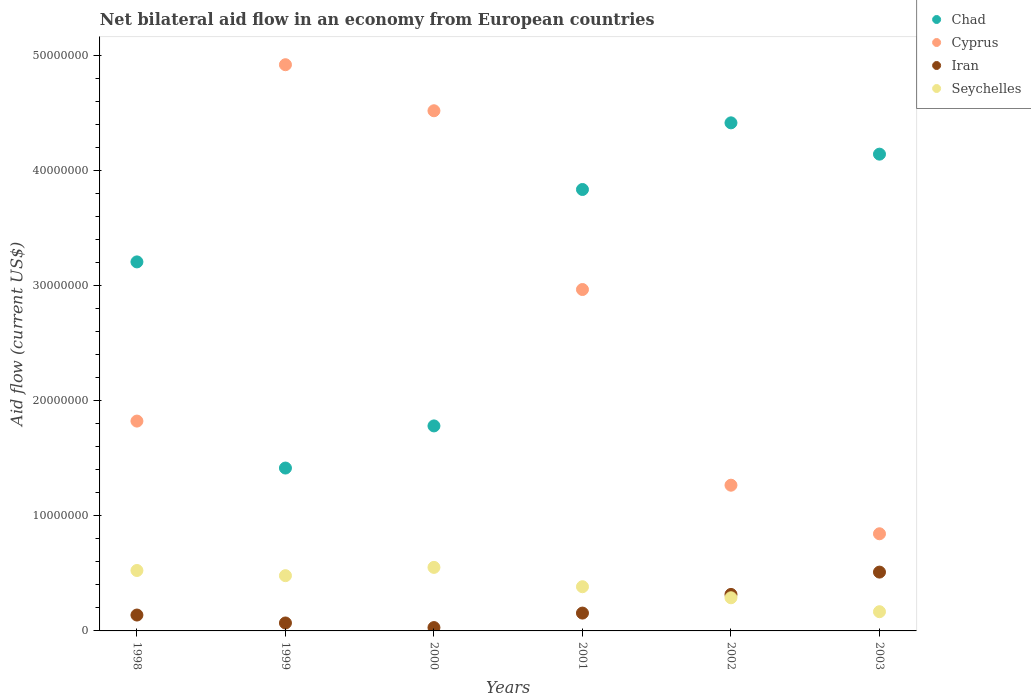What is the net bilateral aid flow in Seychelles in 2000?
Provide a short and direct response. 5.52e+06. Across all years, what is the maximum net bilateral aid flow in Seychelles?
Your answer should be compact. 5.52e+06. Across all years, what is the minimum net bilateral aid flow in Cyprus?
Offer a very short reply. 8.44e+06. In which year was the net bilateral aid flow in Iran maximum?
Your answer should be compact. 2003. What is the total net bilateral aid flow in Iran in the graph?
Ensure brevity in your answer.  1.22e+07. What is the difference between the net bilateral aid flow in Cyprus in 1999 and that in 2000?
Give a very brief answer. 4.00e+06. What is the difference between the net bilateral aid flow in Iran in 2002 and the net bilateral aid flow in Cyprus in 2000?
Offer a very short reply. -4.20e+07. What is the average net bilateral aid flow in Seychelles per year?
Make the answer very short. 3.99e+06. In the year 2003, what is the difference between the net bilateral aid flow in Cyprus and net bilateral aid flow in Seychelles?
Offer a terse response. 6.77e+06. What is the ratio of the net bilateral aid flow in Seychelles in 1998 to that in 2002?
Provide a short and direct response. 1.82. Is the net bilateral aid flow in Chad in 1999 less than that in 2002?
Make the answer very short. Yes. Is the difference between the net bilateral aid flow in Cyprus in 1999 and 2003 greater than the difference between the net bilateral aid flow in Seychelles in 1999 and 2003?
Offer a terse response. Yes. What is the difference between the highest and the second highest net bilateral aid flow in Iran?
Provide a succinct answer. 1.94e+06. What is the difference between the highest and the lowest net bilateral aid flow in Chad?
Provide a short and direct response. 3.00e+07. In how many years, is the net bilateral aid flow in Chad greater than the average net bilateral aid flow in Chad taken over all years?
Keep it short and to the point. 4. Is the sum of the net bilateral aid flow in Seychelles in 1999 and 2001 greater than the maximum net bilateral aid flow in Chad across all years?
Make the answer very short. No. Is it the case that in every year, the sum of the net bilateral aid flow in Chad and net bilateral aid flow in Seychelles  is greater than the net bilateral aid flow in Iran?
Your answer should be compact. Yes. Does the net bilateral aid flow in Seychelles monotonically increase over the years?
Offer a terse response. No. Is the net bilateral aid flow in Seychelles strictly greater than the net bilateral aid flow in Chad over the years?
Provide a short and direct response. No. How many dotlines are there?
Ensure brevity in your answer.  4. Does the graph contain any zero values?
Your response must be concise. No. Does the graph contain grids?
Provide a short and direct response. No. Where does the legend appear in the graph?
Offer a terse response. Top right. What is the title of the graph?
Offer a terse response. Net bilateral aid flow in an economy from European countries. Does "Macao" appear as one of the legend labels in the graph?
Make the answer very short. No. What is the Aid flow (current US$) of Chad in 1998?
Your answer should be compact. 3.21e+07. What is the Aid flow (current US$) in Cyprus in 1998?
Provide a succinct answer. 1.82e+07. What is the Aid flow (current US$) of Iran in 1998?
Ensure brevity in your answer.  1.38e+06. What is the Aid flow (current US$) in Seychelles in 1998?
Keep it short and to the point. 5.25e+06. What is the Aid flow (current US$) of Chad in 1999?
Ensure brevity in your answer.  1.42e+07. What is the Aid flow (current US$) in Cyprus in 1999?
Keep it short and to the point. 4.92e+07. What is the Aid flow (current US$) in Iran in 1999?
Provide a short and direct response. 6.90e+05. What is the Aid flow (current US$) of Seychelles in 1999?
Your answer should be compact. 4.80e+06. What is the Aid flow (current US$) of Chad in 2000?
Keep it short and to the point. 1.78e+07. What is the Aid flow (current US$) in Cyprus in 2000?
Your response must be concise. 4.52e+07. What is the Aid flow (current US$) in Iran in 2000?
Ensure brevity in your answer.  2.90e+05. What is the Aid flow (current US$) in Seychelles in 2000?
Provide a short and direct response. 5.52e+06. What is the Aid flow (current US$) of Chad in 2001?
Give a very brief answer. 3.84e+07. What is the Aid flow (current US$) of Cyprus in 2001?
Provide a succinct answer. 2.97e+07. What is the Aid flow (current US$) in Iran in 2001?
Your answer should be very brief. 1.55e+06. What is the Aid flow (current US$) of Seychelles in 2001?
Keep it short and to the point. 3.84e+06. What is the Aid flow (current US$) of Chad in 2002?
Offer a very short reply. 4.41e+07. What is the Aid flow (current US$) of Cyprus in 2002?
Provide a succinct answer. 1.27e+07. What is the Aid flow (current US$) of Iran in 2002?
Your answer should be very brief. 3.17e+06. What is the Aid flow (current US$) in Seychelles in 2002?
Offer a very short reply. 2.88e+06. What is the Aid flow (current US$) in Chad in 2003?
Provide a succinct answer. 4.14e+07. What is the Aid flow (current US$) of Cyprus in 2003?
Your answer should be compact. 8.44e+06. What is the Aid flow (current US$) of Iran in 2003?
Your answer should be compact. 5.11e+06. What is the Aid flow (current US$) of Seychelles in 2003?
Give a very brief answer. 1.67e+06. Across all years, what is the maximum Aid flow (current US$) in Chad?
Keep it short and to the point. 4.41e+07. Across all years, what is the maximum Aid flow (current US$) in Cyprus?
Your answer should be compact. 4.92e+07. Across all years, what is the maximum Aid flow (current US$) in Iran?
Make the answer very short. 5.11e+06. Across all years, what is the maximum Aid flow (current US$) in Seychelles?
Your response must be concise. 5.52e+06. Across all years, what is the minimum Aid flow (current US$) in Chad?
Ensure brevity in your answer.  1.42e+07. Across all years, what is the minimum Aid flow (current US$) of Cyprus?
Make the answer very short. 8.44e+06. Across all years, what is the minimum Aid flow (current US$) in Seychelles?
Your response must be concise. 1.67e+06. What is the total Aid flow (current US$) of Chad in the graph?
Provide a short and direct response. 1.88e+08. What is the total Aid flow (current US$) of Cyprus in the graph?
Provide a succinct answer. 1.63e+08. What is the total Aid flow (current US$) in Iran in the graph?
Offer a terse response. 1.22e+07. What is the total Aid flow (current US$) in Seychelles in the graph?
Your answer should be compact. 2.40e+07. What is the difference between the Aid flow (current US$) in Chad in 1998 and that in 1999?
Give a very brief answer. 1.79e+07. What is the difference between the Aid flow (current US$) of Cyprus in 1998 and that in 1999?
Offer a very short reply. -3.10e+07. What is the difference between the Aid flow (current US$) in Iran in 1998 and that in 1999?
Make the answer very short. 6.90e+05. What is the difference between the Aid flow (current US$) in Seychelles in 1998 and that in 1999?
Offer a terse response. 4.50e+05. What is the difference between the Aid flow (current US$) in Chad in 1998 and that in 2000?
Give a very brief answer. 1.42e+07. What is the difference between the Aid flow (current US$) in Cyprus in 1998 and that in 2000?
Make the answer very short. -2.70e+07. What is the difference between the Aid flow (current US$) of Iran in 1998 and that in 2000?
Offer a terse response. 1.09e+06. What is the difference between the Aid flow (current US$) in Chad in 1998 and that in 2001?
Keep it short and to the point. -6.29e+06. What is the difference between the Aid flow (current US$) in Cyprus in 1998 and that in 2001?
Give a very brief answer. -1.14e+07. What is the difference between the Aid flow (current US$) in Iran in 1998 and that in 2001?
Keep it short and to the point. -1.70e+05. What is the difference between the Aid flow (current US$) in Seychelles in 1998 and that in 2001?
Offer a terse response. 1.41e+06. What is the difference between the Aid flow (current US$) of Chad in 1998 and that in 2002?
Your answer should be very brief. -1.21e+07. What is the difference between the Aid flow (current US$) in Cyprus in 1998 and that in 2002?
Give a very brief answer. 5.57e+06. What is the difference between the Aid flow (current US$) of Iran in 1998 and that in 2002?
Provide a succinct answer. -1.79e+06. What is the difference between the Aid flow (current US$) of Seychelles in 1998 and that in 2002?
Keep it short and to the point. 2.37e+06. What is the difference between the Aid flow (current US$) in Chad in 1998 and that in 2003?
Offer a very short reply. -9.36e+06. What is the difference between the Aid flow (current US$) of Cyprus in 1998 and that in 2003?
Your response must be concise. 9.79e+06. What is the difference between the Aid flow (current US$) of Iran in 1998 and that in 2003?
Your answer should be compact. -3.73e+06. What is the difference between the Aid flow (current US$) in Seychelles in 1998 and that in 2003?
Provide a succinct answer. 3.58e+06. What is the difference between the Aid flow (current US$) in Chad in 1999 and that in 2000?
Your response must be concise. -3.66e+06. What is the difference between the Aid flow (current US$) of Cyprus in 1999 and that in 2000?
Provide a succinct answer. 4.00e+06. What is the difference between the Aid flow (current US$) in Iran in 1999 and that in 2000?
Provide a short and direct response. 4.00e+05. What is the difference between the Aid flow (current US$) in Seychelles in 1999 and that in 2000?
Give a very brief answer. -7.20e+05. What is the difference between the Aid flow (current US$) in Chad in 1999 and that in 2001?
Keep it short and to the point. -2.42e+07. What is the difference between the Aid flow (current US$) in Cyprus in 1999 and that in 2001?
Your answer should be compact. 1.95e+07. What is the difference between the Aid flow (current US$) of Iran in 1999 and that in 2001?
Your answer should be very brief. -8.60e+05. What is the difference between the Aid flow (current US$) in Seychelles in 1999 and that in 2001?
Provide a succinct answer. 9.60e+05. What is the difference between the Aid flow (current US$) in Chad in 1999 and that in 2002?
Give a very brief answer. -3.00e+07. What is the difference between the Aid flow (current US$) of Cyprus in 1999 and that in 2002?
Your response must be concise. 3.65e+07. What is the difference between the Aid flow (current US$) of Iran in 1999 and that in 2002?
Your answer should be very brief. -2.48e+06. What is the difference between the Aid flow (current US$) of Seychelles in 1999 and that in 2002?
Make the answer very short. 1.92e+06. What is the difference between the Aid flow (current US$) in Chad in 1999 and that in 2003?
Give a very brief answer. -2.73e+07. What is the difference between the Aid flow (current US$) in Cyprus in 1999 and that in 2003?
Offer a very short reply. 4.08e+07. What is the difference between the Aid flow (current US$) of Iran in 1999 and that in 2003?
Make the answer very short. -4.42e+06. What is the difference between the Aid flow (current US$) in Seychelles in 1999 and that in 2003?
Make the answer very short. 3.13e+06. What is the difference between the Aid flow (current US$) of Chad in 2000 and that in 2001?
Give a very brief answer. -2.05e+07. What is the difference between the Aid flow (current US$) in Cyprus in 2000 and that in 2001?
Keep it short and to the point. 1.55e+07. What is the difference between the Aid flow (current US$) of Iran in 2000 and that in 2001?
Offer a very short reply. -1.26e+06. What is the difference between the Aid flow (current US$) of Seychelles in 2000 and that in 2001?
Make the answer very short. 1.68e+06. What is the difference between the Aid flow (current US$) in Chad in 2000 and that in 2002?
Keep it short and to the point. -2.63e+07. What is the difference between the Aid flow (current US$) of Cyprus in 2000 and that in 2002?
Offer a terse response. 3.25e+07. What is the difference between the Aid flow (current US$) of Iran in 2000 and that in 2002?
Your answer should be compact. -2.88e+06. What is the difference between the Aid flow (current US$) of Seychelles in 2000 and that in 2002?
Your answer should be very brief. 2.64e+06. What is the difference between the Aid flow (current US$) of Chad in 2000 and that in 2003?
Offer a very short reply. -2.36e+07. What is the difference between the Aid flow (current US$) of Cyprus in 2000 and that in 2003?
Your answer should be very brief. 3.68e+07. What is the difference between the Aid flow (current US$) in Iran in 2000 and that in 2003?
Make the answer very short. -4.82e+06. What is the difference between the Aid flow (current US$) in Seychelles in 2000 and that in 2003?
Provide a short and direct response. 3.85e+06. What is the difference between the Aid flow (current US$) in Chad in 2001 and that in 2002?
Your response must be concise. -5.79e+06. What is the difference between the Aid flow (current US$) of Cyprus in 2001 and that in 2002?
Give a very brief answer. 1.70e+07. What is the difference between the Aid flow (current US$) of Iran in 2001 and that in 2002?
Your answer should be compact. -1.62e+06. What is the difference between the Aid flow (current US$) of Seychelles in 2001 and that in 2002?
Ensure brevity in your answer.  9.60e+05. What is the difference between the Aid flow (current US$) of Chad in 2001 and that in 2003?
Keep it short and to the point. -3.07e+06. What is the difference between the Aid flow (current US$) of Cyprus in 2001 and that in 2003?
Provide a short and direct response. 2.12e+07. What is the difference between the Aid flow (current US$) in Iran in 2001 and that in 2003?
Provide a short and direct response. -3.56e+06. What is the difference between the Aid flow (current US$) of Seychelles in 2001 and that in 2003?
Your answer should be compact. 2.17e+06. What is the difference between the Aid flow (current US$) of Chad in 2002 and that in 2003?
Make the answer very short. 2.72e+06. What is the difference between the Aid flow (current US$) of Cyprus in 2002 and that in 2003?
Keep it short and to the point. 4.22e+06. What is the difference between the Aid flow (current US$) in Iran in 2002 and that in 2003?
Provide a short and direct response. -1.94e+06. What is the difference between the Aid flow (current US$) in Seychelles in 2002 and that in 2003?
Your answer should be compact. 1.21e+06. What is the difference between the Aid flow (current US$) of Chad in 1998 and the Aid flow (current US$) of Cyprus in 1999?
Make the answer very short. -1.71e+07. What is the difference between the Aid flow (current US$) in Chad in 1998 and the Aid flow (current US$) in Iran in 1999?
Offer a terse response. 3.14e+07. What is the difference between the Aid flow (current US$) of Chad in 1998 and the Aid flow (current US$) of Seychelles in 1999?
Your answer should be very brief. 2.73e+07. What is the difference between the Aid flow (current US$) in Cyprus in 1998 and the Aid flow (current US$) in Iran in 1999?
Make the answer very short. 1.75e+07. What is the difference between the Aid flow (current US$) in Cyprus in 1998 and the Aid flow (current US$) in Seychelles in 1999?
Give a very brief answer. 1.34e+07. What is the difference between the Aid flow (current US$) in Iran in 1998 and the Aid flow (current US$) in Seychelles in 1999?
Your response must be concise. -3.42e+06. What is the difference between the Aid flow (current US$) of Chad in 1998 and the Aid flow (current US$) of Cyprus in 2000?
Provide a short and direct response. -1.31e+07. What is the difference between the Aid flow (current US$) in Chad in 1998 and the Aid flow (current US$) in Iran in 2000?
Your answer should be very brief. 3.18e+07. What is the difference between the Aid flow (current US$) in Chad in 1998 and the Aid flow (current US$) in Seychelles in 2000?
Your answer should be compact. 2.65e+07. What is the difference between the Aid flow (current US$) of Cyprus in 1998 and the Aid flow (current US$) of Iran in 2000?
Your response must be concise. 1.79e+07. What is the difference between the Aid flow (current US$) in Cyprus in 1998 and the Aid flow (current US$) in Seychelles in 2000?
Keep it short and to the point. 1.27e+07. What is the difference between the Aid flow (current US$) of Iran in 1998 and the Aid flow (current US$) of Seychelles in 2000?
Offer a terse response. -4.14e+06. What is the difference between the Aid flow (current US$) of Chad in 1998 and the Aid flow (current US$) of Cyprus in 2001?
Give a very brief answer. 2.40e+06. What is the difference between the Aid flow (current US$) of Chad in 1998 and the Aid flow (current US$) of Iran in 2001?
Keep it short and to the point. 3.05e+07. What is the difference between the Aid flow (current US$) in Chad in 1998 and the Aid flow (current US$) in Seychelles in 2001?
Give a very brief answer. 2.82e+07. What is the difference between the Aid flow (current US$) of Cyprus in 1998 and the Aid flow (current US$) of Iran in 2001?
Give a very brief answer. 1.67e+07. What is the difference between the Aid flow (current US$) of Cyprus in 1998 and the Aid flow (current US$) of Seychelles in 2001?
Make the answer very short. 1.44e+07. What is the difference between the Aid flow (current US$) in Iran in 1998 and the Aid flow (current US$) in Seychelles in 2001?
Give a very brief answer. -2.46e+06. What is the difference between the Aid flow (current US$) of Chad in 1998 and the Aid flow (current US$) of Cyprus in 2002?
Offer a very short reply. 1.94e+07. What is the difference between the Aid flow (current US$) in Chad in 1998 and the Aid flow (current US$) in Iran in 2002?
Keep it short and to the point. 2.89e+07. What is the difference between the Aid flow (current US$) in Chad in 1998 and the Aid flow (current US$) in Seychelles in 2002?
Your answer should be very brief. 2.92e+07. What is the difference between the Aid flow (current US$) of Cyprus in 1998 and the Aid flow (current US$) of Iran in 2002?
Make the answer very short. 1.51e+07. What is the difference between the Aid flow (current US$) in Cyprus in 1998 and the Aid flow (current US$) in Seychelles in 2002?
Offer a terse response. 1.54e+07. What is the difference between the Aid flow (current US$) in Iran in 1998 and the Aid flow (current US$) in Seychelles in 2002?
Your answer should be compact. -1.50e+06. What is the difference between the Aid flow (current US$) in Chad in 1998 and the Aid flow (current US$) in Cyprus in 2003?
Your answer should be very brief. 2.36e+07. What is the difference between the Aid flow (current US$) of Chad in 1998 and the Aid flow (current US$) of Iran in 2003?
Provide a short and direct response. 2.70e+07. What is the difference between the Aid flow (current US$) of Chad in 1998 and the Aid flow (current US$) of Seychelles in 2003?
Make the answer very short. 3.04e+07. What is the difference between the Aid flow (current US$) in Cyprus in 1998 and the Aid flow (current US$) in Iran in 2003?
Offer a terse response. 1.31e+07. What is the difference between the Aid flow (current US$) in Cyprus in 1998 and the Aid flow (current US$) in Seychelles in 2003?
Provide a succinct answer. 1.66e+07. What is the difference between the Aid flow (current US$) of Chad in 1999 and the Aid flow (current US$) of Cyprus in 2000?
Offer a very short reply. -3.10e+07. What is the difference between the Aid flow (current US$) of Chad in 1999 and the Aid flow (current US$) of Iran in 2000?
Provide a short and direct response. 1.39e+07. What is the difference between the Aid flow (current US$) of Chad in 1999 and the Aid flow (current US$) of Seychelles in 2000?
Give a very brief answer. 8.63e+06. What is the difference between the Aid flow (current US$) of Cyprus in 1999 and the Aid flow (current US$) of Iran in 2000?
Your answer should be compact. 4.89e+07. What is the difference between the Aid flow (current US$) in Cyprus in 1999 and the Aid flow (current US$) in Seychelles in 2000?
Your response must be concise. 4.37e+07. What is the difference between the Aid flow (current US$) of Iran in 1999 and the Aid flow (current US$) of Seychelles in 2000?
Ensure brevity in your answer.  -4.83e+06. What is the difference between the Aid flow (current US$) of Chad in 1999 and the Aid flow (current US$) of Cyprus in 2001?
Provide a succinct answer. -1.55e+07. What is the difference between the Aid flow (current US$) of Chad in 1999 and the Aid flow (current US$) of Iran in 2001?
Ensure brevity in your answer.  1.26e+07. What is the difference between the Aid flow (current US$) of Chad in 1999 and the Aid flow (current US$) of Seychelles in 2001?
Ensure brevity in your answer.  1.03e+07. What is the difference between the Aid flow (current US$) in Cyprus in 1999 and the Aid flow (current US$) in Iran in 2001?
Your answer should be compact. 4.76e+07. What is the difference between the Aid flow (current US$) of Cyprus in 1999 and the Aid flow (current US$) of Seychelles in 2001?
Give a very brief answer. 4.54e+07. What is the difference between the Aid flow (current US$) in Iran in 1999 and the Aid flow (current US$) in Seychelles in 2001?
Make the answer very short. -3.15e+06. What is the difference between the Aid flow (current US$) in Chad in 1999 and the Aid flow (current US$) in Cyprus in 2002?
Provide a succinct answer. 1.49e+06. What is the difference between the Aid flow (current US$) of Chad in 1999 and the Aid flow (current US$) of Iran in 2002?
Offer a very short reply. 1.10e+07. What is the difference between the Aid flow (current US$) of Chad in 1999 and the Aid flow (current US$) of Seychelles in 2002?
Provide a succinct answer. 1.13e+07. What is the difference between the Aid flow (current US$) in Cyprus in 1999 and the Aid flow (current US$) in Iran in 2002?
Provide a short and direct response. 4.60e+07. What is the difference between the Aid flow (current US$) in Cyprus in 1999 and the Aid flow (current US$) in Seychelles in 2002?
Offer a terse response. 4.63e+07. What is the difference between the Aid flow (current US$) in Iran in 1999 and the Aid flow (current US$) in Seychelles in 2002?
Provide a succinct answer. -2.19e+06. What is the difference between the Aid flow (current US$) in Chad in 1999 and the Aid flow (current US$) in Cyprus in 2003?
Your answer should be very brief. 5.71e+06. What is the difference between the Aid flow (current US$) in Chad in 1999 and the Aid flow (current US$) in Iran in 2003?
Offer a terse response. 9.04e+06. What is the difference between the Aid flow (current US$) in Chad in 1999 and the Aid flow (current US$) in Seychelles in 2003?
Ensure brevity in your answer.  1.25e+07. What is the difference between the Aid flow (current US$) in Cyprus in 1999 and the Aid flow (current US$) in Iran in 2003?
Ensure brevity in your answer.  4.41e+07. What is the difference between the Aid flow (current US$) of Cyprus in 1999 and the Aid flow (current US$) of Seychelles in 2003?
Make the answer very short. 4.75e+07. What is the difference between the Aid flow (current US$) in Iran in 1999 and the Aid flow (current US$) in Seychelles in 2003?
Provide a short and direct response. -9.80e+05. What is the difference between the Aid flow (current US$) in Chad in 2000 and the Aid flow (current US$) in Cyprus in 2001?
Your answer should be compact. -1.18e+07. What is the difference between the Aid flow (current US$) in Chad in 2000 and the Aid flow (current US$) in Iran in 2001?
Your answer should be very brief. 1.63e+07. What is the difference between the Aid flow (current US$) in Chad in 2000 and the Aid flow (current US$) in Seychelles in 2001?
Provide a succinct answer. 1.40e+07. What is the difference between the Aid flow (current US$) of Cyprus in 2000 and the Aid flow (current US$) of Iran in 2001?
Your answer should be very brief. 4.36e+07. What is the difference between the Aid flow (current US$) of Cyprus in 2000 and the Aid flow (current US$) of Seychelles in 2001?
Your answer should be very brief. 4.14e+07. What is the difference between the Aid flow (current US$) of Iran in 2000 and the Aid flow (current US$) of Seychelles in 2001?
Your answer should be very brief. -3.55e+06. What is the difference between the Aid flow (current US$) of Chad in 2000 and the Aid flow (current US$) of Cyprus in 2002?
Offer a very short reply. 5.15e+06. What is the difference between the Aid flow (current US$) in Chad in 2000 and the Aid flow (current US$) in Iran in 2002?
Ensure brevity in your answer.  1.46e+07. What is the difference between the Aid flow (current US$) in Chad in 2000 and the Aid flow (current US$) in Seychelles in 2002?
Your answer should be compact. 1.49e+07. What is the difference between the Aid flow (current US$) of Cyprus in 2000 and the Aid flow (current US$) of Iran in 2002?
Offer a terse response. 4.20e+07. What is the difference between the Aid flow (current US$) of Cyprus in 2000 and the Aid flow (current US$) of Seychelles in 2002?
Ensure brevity in your answer.  4.23e+07. What is the difference between the Aid flow (current US$) of Iran in 2000 and the Aid flow (current US$) of Seychelles in 2002?
Provide a short and direct response. -2.59e+06. What is the difference between the Aid flow (current US$) in Chad in 2000 and the Aid flow (current US$) in Cyprus in 2003?
Offer a terse response. 9.37e+06. What is the difference between the Aid flow (current US$) in Chad in 2000 and the Aid flow (current US$) in Iran in 2003?
Keep it short and to the point. 1.27e+07. What is the difference between the Aid flow (current US$) of Chad in 2000 and the Aid flow (current US$) of Seychelles in 2003?
Your answer should be compact. 1.61e+07. What is the difference between the Aid flow (current US$) in Cyprus in 2000 and the Aid flow (current US$) in Iran in 2003?
Your response must be concise. 4.01e+07. What is the difference between the Aid flow (current US$) in Cyprus in 2000 and the Aid flow (current US$) in Seychelles in 2003?
Provide a succinct answer. 4.35e+07. What is the difference between the Aid flow (current US$) in Iran in 2000 and the Aid flow (current US$) in Seychelles in 2003?
Provide a succinct answer. -1.38e+06. What is the difference between the Aid flow (current US$) in Chad in 2001 and the Aid flow (current US$) in Cyprus in 2002?
Keep it short and to the point. 2.57e+07. What is the difference between the Aid flow (current US$) of Chad in 2001 and the Aid flow (current US$) of Iran in 2002?
Your answer should be compact. 3.52e+07. What is the difference between the Aid flow (current US$) of Chad in 2001 and the Aid flow (current US$) of Seychelles in 2002?
Ensure brevity in your answer.  3.55e+07. What is the difference between the Aid flow (current US$) of Cyprus in 2001 and the Aid flow (current US$) of Iran in 2002?
Your answer should be very brief. 2.65e+07. What is the difference between the Aid flow (current US$) in Cyprus in 2001 and the Aid flow (current US$) in Seychelles in 2002?
Offer a very short reply. 2.68e+07. What is the difference between the Aid flow (current US$) in Iran in 2001 and the Aid flow (current US$) in Seychelles in 2002?
Ensure brevity in your answer.  -1.33e+06. What is the difference between the Aid flow (current US$) in Chad in 2001 and the Aid flow (current US$) in Cyprus in 2003?
Provide a short and direct response. 2.99e+07. What is the difference between the Aid flow (current US$) in Chad in 2001 and the Aid flow (current US$) in Iran in 2003?
Your response must be concise. 3.32e+07. What is the difference between the Aid flow (current US$) in Chad in 2001 and the Aid flow (current US$) in Seychelles in 2003?
Provide a short and direct response. 3.67e+07. What is the difference between the Aid flow (current US$) in Cyprus in 2001 and the Aid flow (current US$) in Iran in 2003?
Provide a short and direct response. 2.46e+07. What is the difference between the Aid flow (current US$) of Cyprus in 2001 and the Aid flow (current US$) of Seychelles in 2003?
Keep it short and to the point. 2.80e+07. What is the difference between the Aid flow (current US$) in Chad in 2002 and the Aid flow (current US$) in Cyprus in 2003?
Offer a very short reply. 3.57e+07. What is the difference between the Aid flow (current US$) of Chad in 2002 and the Aid flow (current US$) of Iran in 2003?
Your answer should be very brief. 3.90e+07. What is the difference between the Aid flow (current US$) in Chad in 2002 and the Aid flow (current US$) in Seychelles in 2003?
Provide a succinct answer. 4.25e+07. What is the difference between the Aid flow (current US$) of Cyprus in 2002 and the Aid flow (current US$) of Iran in 2003?
Offer a terse response. 7.55e+06. What is the difference between the Aid flow (current US$) in Cyprus in 2002 and the Aid flow (current US$) in Seychelles in 2003?
Keep it short and to the point. 1.10e+07. What is the difference between the Aid flow (current US$) of Iran in 2002 and the Aid flow (current US$) of Seychelles in 2003?
Offer a very short reply. 1.50e+06. What is the average Aid flow (current US$) in Chad per year?
Offer a terse response. 3.13e+07. What is the average Aid flow (current US$) in Cyprus per year?
Provide a succinct answer. 2.72e+07. What is the average Aid flow (current US$) of Iran per year?
Offer a very short reply. 2.03e+06. What is the average Aid flow (current US$) in Seychelles per year?
Your answer should be very brief. 3.99e+06. In the year 1998, what is the difference between the Aid flow (current US$) in Chad and Aid flow (current US$) in Cyprus?
Ensure brevity in your answer.  1.38e+07. In the year 1998, what is the difference between the Aid flow (current US$) in Chad and Aid flow (current US$) in Iran?
Ensure brevity in your answer.  3.07e+07. In the year 1998, what is the difference between the Aid flow (current US$) in Chad and Aid flow (current US$) in Seychelles?
Offer a very short reply. 2.68e+07. In the year 1998, what is the difference between the Aid flow (current US$) in Cyprus and Aid flow (current US$) in Iran?
Your response must be concise. 1.68e+07. In the year 1998, what is the difference between the Aid flow (current US$) in Cyprus and Aid flow (current US$) in Seychelles?
Make the answer very short. 1.30e+07. In the year 1998, what is the difference between the Aid flow (current US$) of Iran and Aid flow (current US$) of Seychelles?
Keep it short and to the point. -3.87e+06. In the year 1999, what is the difference between the Aid flow (current US$) in Chad and Aid flow (current US$) in Cyprus?
Your answer should be compact. -3.50e+07. In the year 1999, what is the difference between the Aid flow (current US$) in Chad and Aid flow (current US$) in Iran?
Your answer should be very brief. 1.35e+07. In the year 1999, what is the difference between the Aid flow (current US$) of Chad and Aid flow (current US$) of Seychelles?
Offer a very short reply. 9.35e+06. In the year 1999, what is the difference between the Aid flow (current US$) of Cyprus and Aid flow (current US$) of Iran?
Give a very brief answer. 4.85e+07. In the year 1999, what is the difference between the Aid flow (current US$) of Cyprus and Aid flow (current US$) of Seychelles?
Your answer should be very brief. 4.44e+07. In the year 1999, what is the difference between the Aid flow (current US$) of Iran and Aid flow (current US$) of Seychelles?
Offer a terse response. -4.11e+06. In the year 2000, what is the difference between the Aid flow (current US$) of Chad and Aid flow (current US$) of Cyprus?
Make the answer very short. -2.74e+07. In the year 2000, what is the difference between the Aid flow (current US$) in Chad and Aid flow (current US$) in Iran?
Offer a terse response. 1.75e+07. In the year 2000, what is the difference between the Aid flow (current US$) in Chad and Aid flow (current US$) in Seychelles?
Keep it short and to the point. 1.23e+07. In the year 2000, what is the difference between the Aid flow (current US$) in Cyprus and Aid flow (current US$) in Iran?
Your response must be concise. 4.49e+07. In the year 2000, what is the difference between the Aid flow (current US$) of Cyprus and Aid flow (current US$) of Seychelles?
Keep it short and to the point. 3.97e+07. In the year 2000, what is the difference between the Aid flow (current US$) of Iran and Aid flow (current US$) of Seychelles?
Your response must be concise. -5.23e+06. In the year 2001, what is the difference between the Aid flow (current US$) of Chad and Aid flow (current US$) of Cyprus?
Your response must be concise. 8.69e+06. In the year 2001, what is the difference between the Aid flow (current US$) in Chad and Aid flow (current US$) in Iran?
Provide a short and direct response. 3.68e+07. In the year 2001, what is the difference between the Aid flow (current US$) of Chad and Aid flow (current US$) of Seychelles?
Provide a succinct answer. 3.45e+07. In the year 2001, what is the difference between the Aid flow (current US$) of Cyprus and Aid flow (current US$) of Iran?
Offer a terse response. 2.81e+07. In the year 2001, what is the difference between the Aid flow (current US$) of Cyprus and Aid flow (current US$) of Seychelles?
Offer a very short reply. 2.58e+07. In the year 2001, what is the difference between the Aid flow (current US$) of Iran and Aid flow (current US$) of Seychelles?
Your answer should be compact. -2.29e+06. In the year 2002, what is the difference between the Aid flow (current US$) in Chad and Aid flow (current US$) in Cyprus?
Give a very brief answer. 3.15e+07. In the year 2002, what is the difference between the Aid flow (current US$) of Chad and Aid flow (current US$) of Iran?
Your response must be concise. 4.10e+07. In the year 2002, what is the difference between the Aid flow (current US$) of Chad and Aid flow (current US$) of Seychelles?
Your response must be concise. 4.13e+07. In the year 2002, what is the difference between the Aid flow (current US$) of Cyprus and Aid flow (current US$) of Iran?
Your response must be concise. 9.49e+06. In the year 2002, what is the difference between the Aid flow (current US$) of Cyprus and Aid flow (current US$) of Seychelles?
Keep it short and to the point. 9.78e+06. In the year 2003, what is the difference between the Aid flow (current US$) in Chad and Aid flow (current US$) in Cyprus?
Provide a short and direct response. 3.30e+07. In the year 2003, what is the difference between the Aid flow (current US$) in Chad and Aid flow (current US$) in Iran?
Provide a short and direct response. 3.63e+07. In the year 2003, what is the difference between the Aid flow (current US$) of Chad and Aid flow (current US$) of Seychelles?
Ensure brevity in your answer.  3.98e+07. In the year 2003, what is the difference between the Aid flow (current US$) in Cyprus and Aid flow (current US$) in Iran?
Your response must be concise. 3.33e+06. In the year 2003, what is the difference between the Aid flow (current US$) in Cyprus and Aid flow (current US$) in Seychelles?
Offer a very short reply. 6.77e+06. In the year 2003, what is the difference between the Aid flow (current US$) in Iran and Aid flow (current US$) in Seychelles?
Keep it short and to the point. 3.44e+06. What is the ratio of the Aid flow (current US$) of Chad in 1998 to that in 1999?
Ensure brevity in your answer.  2.27. What is the ratio of the Aid flow (current US$) of Cyprus in 1998 to that in 1999?
Offer a very short reply. 0.37. What is the ratio of the Aid flow (current US$) in Seychelles in 1998 to that in 1999?
Offer a very short reply. 1.09. What is the ratio of the Aid flow (current US$) in Chad in 1998 to that in 2000?
Keep it short and to the point. 1.8. What is the ratio of the Aid flow (current US$) in Cyprus in 1998 to that in 2000?
Provide a succinct answer. 0.4. What is the ratio of the Aid flow (current US$) in Iran in 1998 to that in 2000?
Your answer should be compact. 4.76. What is the ratio of the Aid flow (current US$) of Seychelles in 1998 to that in 2000?
Offer a terse response. 0.95. What is the ratio of the Aid flow (current US$) in Chad in 1998 to that in 2001?
Provide a short and direct response. 0.84. What is the ratio of the Aid flow (current US$) of Cyprus in 1998 to that in 2001?
Give a very brief answer. 0.61. What is the ratio of the Aid flow (current US$) of Iran in 1998 to that in 2001?
Keep it short and to the point. 0.89. What is the ratio of the Aid flow (current US$) in Seychelles in 1998 to that in 2001?
Provide a short and direct response. 1.37. What is the ratio of the Aid flow (current US$) of Chad in 1998 to that in 2002?
Your response must be concise. 0.73. What is the ratio of the Aid flow (current US$) in Cyprus in 1998 to that in 2002?
Your response must be concise. 1.44. What is the ratio of the Aid flow (current US$) in Iran in 1998 to that in 2002?
Ensure brevity in your answer.  0.44. What is the ratio of the Aid flow (current US$) of Seychelles in 1998 to that in 2002?
Provide a short and direct response. 1.82. What is the ratio of the Aid flow (current US$) in Chad in 1998 to that in 2003?
Provide a succinct answer. 0.77. What is the ratio of the Aid flow (current US$) in Cyprus in 1998 to that in 2003?
Give a very brief answer. 2.16. What is the ratio of the Aid flow (current US$) in Iran in 1998 to that in 2003?
Make the answer very short. 0.27. What is the ratio of the Aid flow (current US$) in Seychelles in 1998 to that in 2003?
Give a very brief answer. 3.14. What is the ratio of the Aid flow (current US$) of Chad in 1999 to that in 2000?
Your response must be concise. 0.79. What is the ratio of the Aid flow (current US$) of Cyprus in 1999 to that in 2000?
Your answer should be compact. 1.09. What is the ratio of the Aid flow (current US$) of Iran in 1999 to that in 2000?
Offer a very short reply. 2.38. What is the ratio of the Aid flow (current US$) of Seychelles in 1999 to that in 2000?
Ensure brevity in your answer.  0.87. What is the ratio of the Aid flow (current US$) of Chad in 1999 to that in 2001?
Give a very brief answer. 0.37. What is the ratio of the Aid flow (current US$) of Cyprus in 1999 to that in 2001?
Your response must be concise. 1.66. What is the ratio of the Aid flow (current US$) of Iran in 1999 to that in 2001?
Offer a very short reply. 0.45. What is the ratio of the Aid flow (current US$) of Chad in 1999 to that in 2002?
Ensure brevity in your answer.  0.32. What is the ratio of the Aid flow (current US$) of Cyprus in 1999 to that in 2002?
Ensure brevity in your answer.  3.89. What is the ratio of the Aid flow (current US$) in Iran in 1999 to that in 2002?
Your answer should be very brief. 0.22. What is the ratio of the Aid flow (current US$) of Chad in 1999 to that in 2003?
Offer a terse response. 0.34. What is the ratio of the Aid flow (current US$) in Cyprus in 1999 to that in 2003?
Ensure brevity in your answer.  5.83. What is the ratio of the Aid flow (current US$) of Iran in 1999 to that in 2003?
Make the answer very short. 0.14. What is the ratio of the Aid flow (current US$) in Seychelles in 1999 to that in 2003?
Provide a succinct answer. 2.87. What is the ratio of the Aid flow (current US$) of Chad in 2000 to that in 2001?
Ensure brevity in your answer.  0.46. What is the ratio of the Aid flow (current US$) in Cyprus in 2000 to that in 2001?
Your answer should be compact. 1.52. What is the ratio of the Aid flow (current US$) in Iran in 2000 to that in 2001?
Keep it short and to the point. 0.19. What is the ratio of the Aid flow (current US$) of Seychelles in 2000 to that in 2001?
Provide a short and direct response. 1.44. What is the ratio of the Aid flow (current US$) of Chad in 2000 to that in 2002?
Offer a terse response. 0.4. What is the ratio of the Aid flow (current US$) in Cyprus in 2000 to that in 2002?
Give a very brief answer. 3.57. What is the ratio of the Aid flow (current US$) of Iran in 2000 to that in 2002?
Your response must be concise. 0.09. What is the ratio of the Aid flow (current US$) in Seychelles in 2000 to that in 2002?
Offer a terse response. 1.92. What is the ratio of the Aid flow (current US$) of Chad in 2000 to that in 2003?
Keep it short and to the point. 0.43. What is the ratio of the Aid flow (current US$) in Cyprus in 2000 to that in 2003?
Your answer should be compact. 5.35. What is the ratio of the Aid flow (current US$) of Iran in 2000 to that in 2003?
Provide a succinct answer. 0.06. What is the ratio of the Aid flow (current US$) in Seychelles in 2000 to that in 2003?
Your response must be concise. 3.31. What is the ratio of the Aid flow (current US$) of Chad in 2001 to that in 2002?
Provide a succinct answer. 0.87. What is the ratio of the Aid flow (current US$) in Cyprus in 2001 to that in 2002?
Offer a terse response. 2.34. What is the ratio of the Aid flow (current US$) of Iran in 2001 to that in 2002?
Offer a very short reply. 0.49. What is the ratio of the Aid flow (current US$) of Chad in 2001 to that in 2003?
Give a very brief answer. 0.93. What is the ratio of the Aid flow (current US$) of Cyprus in 2001 to that in 2003?
Offer a terse response. 3.51. What is the ratio of the Aid flow (current US$) in Iran in 2001 to that in 2003?
Your response must be concise. 0.3. What is the ratio of the Aid flow (current US$) in Seychelles in 2001 to that in 2003?
Your response must be concise. 2.3. What is the ratio of the Aid flow (current US$) of Chad in 2002 to that in 2003?
Offer a very short reply. 1.07. What is the ratio of the Aid flow (current US$) of Cyprus in 2002 to that in 2003?
Provide a succinct answer. 1.5. What is the ratio of the Aid flow (current US$) of Iran in 2002 to that in 2003?
Provide a short and direct response. 0.62. What is the ratio of the Aid flow (current US$) in Seychelles in 2002 to that in 2003?
Your answer should be compact. 1.72. What is the difference between the highest and the second highest Aid flow (current US$) in Chad?
Provide a short and direct response. 2.72e+06. What is the difference between the highest and the second highest Aid flow (current US$) of Cyprus?
Provide a short and direct response. 4.00e+06. What is the difference between the highest and the second highest Aid flow (current US$) of Iran?
Make the answer very short. 1.94e+06. What is the difference between the highest and the second highest Aid flow (current US$) in Seychelles?
Make the answer very short. 2.70e+05. What is the difference between the highest and the lowest Aid flow (current US$) of Chad?
Provide a short and direct response. 3.00e+07. What is the difference between the highest and the lowest Aid flow (current US$) in Cyprus?
Give a very brief answer. 4.08e+07. What is the difference between the highest and the lowest Aid flow (current US$) of Iran?
Provide a short and direct response. 4.82e+06. What is the difference between the highest and the lowest Aid flow (current US$) of Seychelles?
Your answer should be compact. 3.85e+06. 